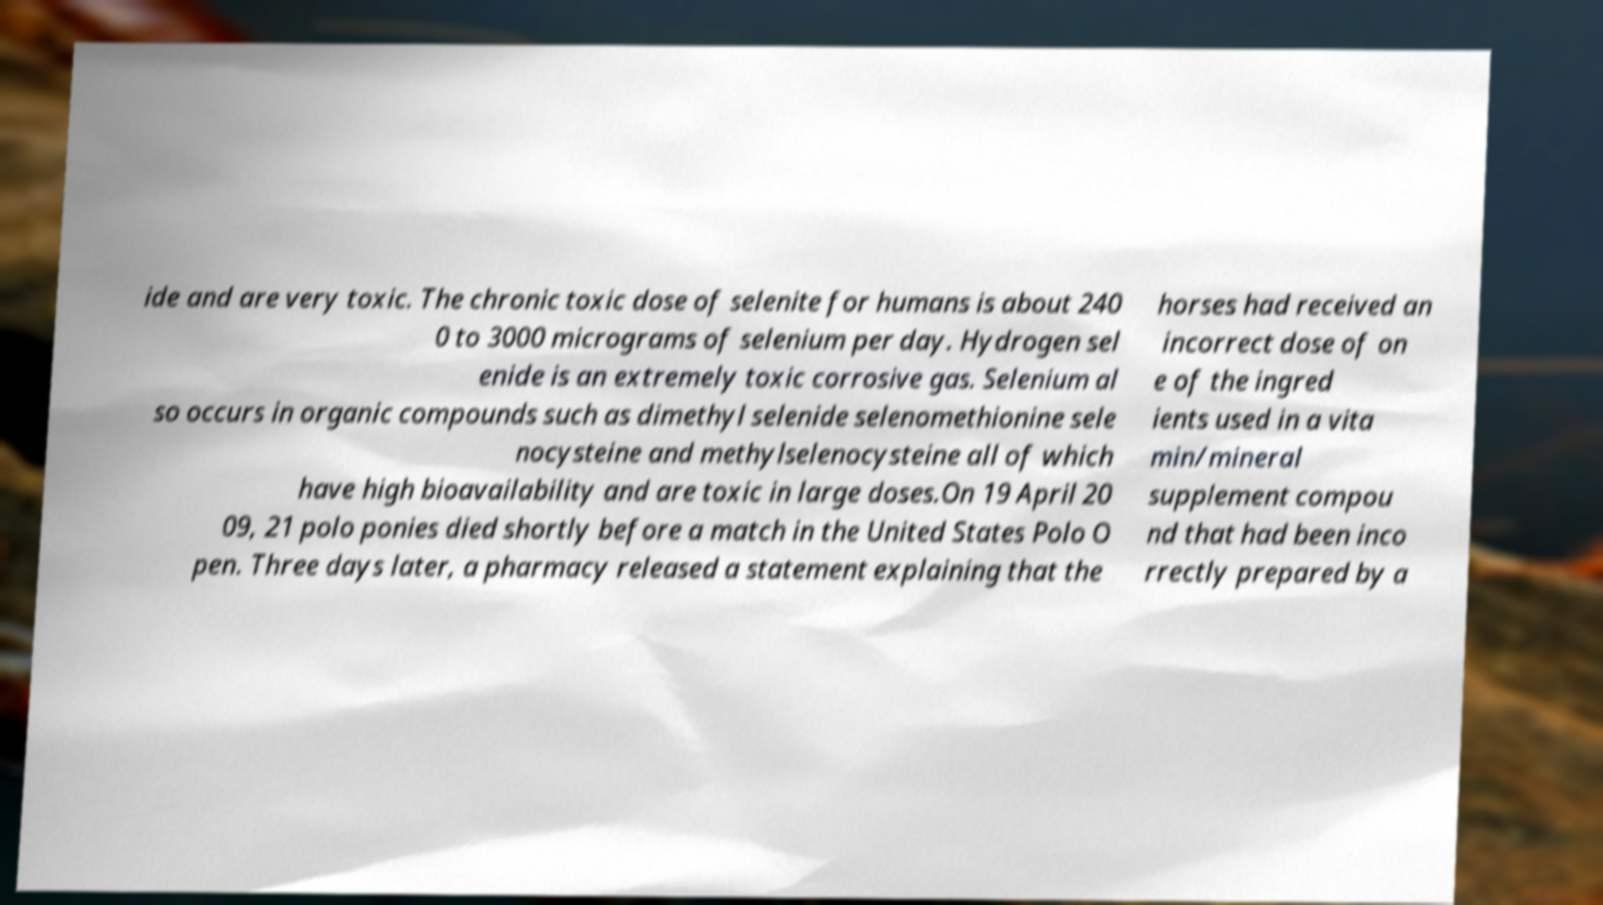Can you accurately transcribe the text from the provided image for me? ide and are very toxic. The chronic toxic dose of selenite for humans is about 240 0 to 3000 micrograms of selenium per day. Hydrogen sel enide is an extremely toxic corrosive gas. Selenium al so occurs in organic compounds such as dimethyl selenide selenomethionine sele nocysteine and methylselenocysteine all of which have high bioavailability and are toxic in large doses.On 19 April 20 09, 21 polo ponies died shortly before a match in the United States Polo O pen. Three days later, a pharmacy released a statement explaining that the horses had received an incorrect dose of on e of the ingred ients used in a vita min/mineral supplement compou nd that had been inco rrectly prepared by a 